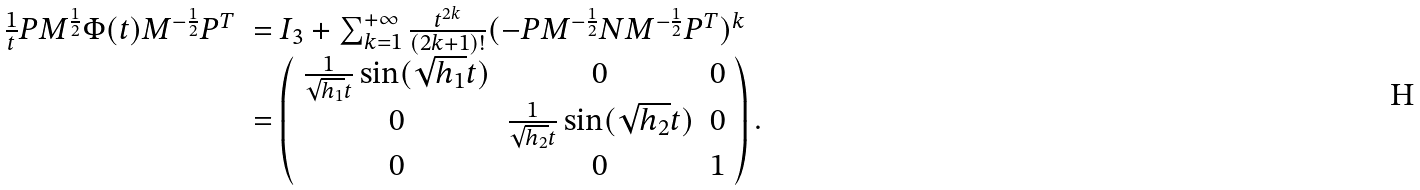Convert formula to latex. <formula><loc_0><loc_0><loc_500><loc_500>\begin{array} { l l } \frac { 1 } { t } P M ^ { \frac { 1 } { 2 } } \Phi ( t ) M ^ { - \frac { 1 } { 2 } } P ^ { T } & = I _ { 3 } + \sum _ { k = 1 } ^ { + \infty } \frac { t ^ { 2 k } } { ( 2 k + 1 ) ! } ( - P M ^ { - \frac { 1 } { 2 } } N M ^ { - \frac { 1 } { 2 } } P ^ { T } ) ^ { k } \\ & = \left ( \begin{array} { c c c } \frac { 1 } { \sqrt { h _ { 1 } } t } \sin ( \sqrt { h _ { 1 } } t ) & 0 & 0 \\ 0 & \frac { 1 } { \sqrt { h _ { 2 } } t } \sin ( \sqrt { h _ { 2 } } t ) & 0 \\ 0 & 0 & 1 \end{array} \right ) . \end{array}</formula> 